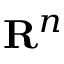Convert formula to latex. <formula><loc_0><loc_0><loc_500><loc_500>{ R } ^ { n }</formula> 